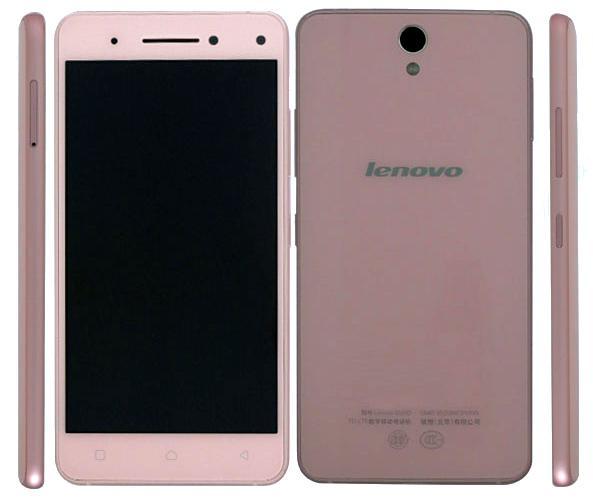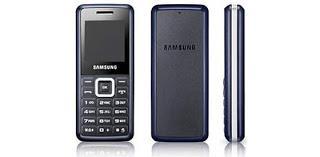The first image is the image on the left, the second image is the image on the right. Examine the images to the left and right. Is the description "There is a side profile of at least one phone." accurate? Answer yes or no. Yes. The first image is the image on the left, the second image is the image on the right. For the images displayed, is the sentence "At least one image includes a side-view of a phone to the right of two head-on displayed devices." factually correct? Answer yes or no. Yes. 